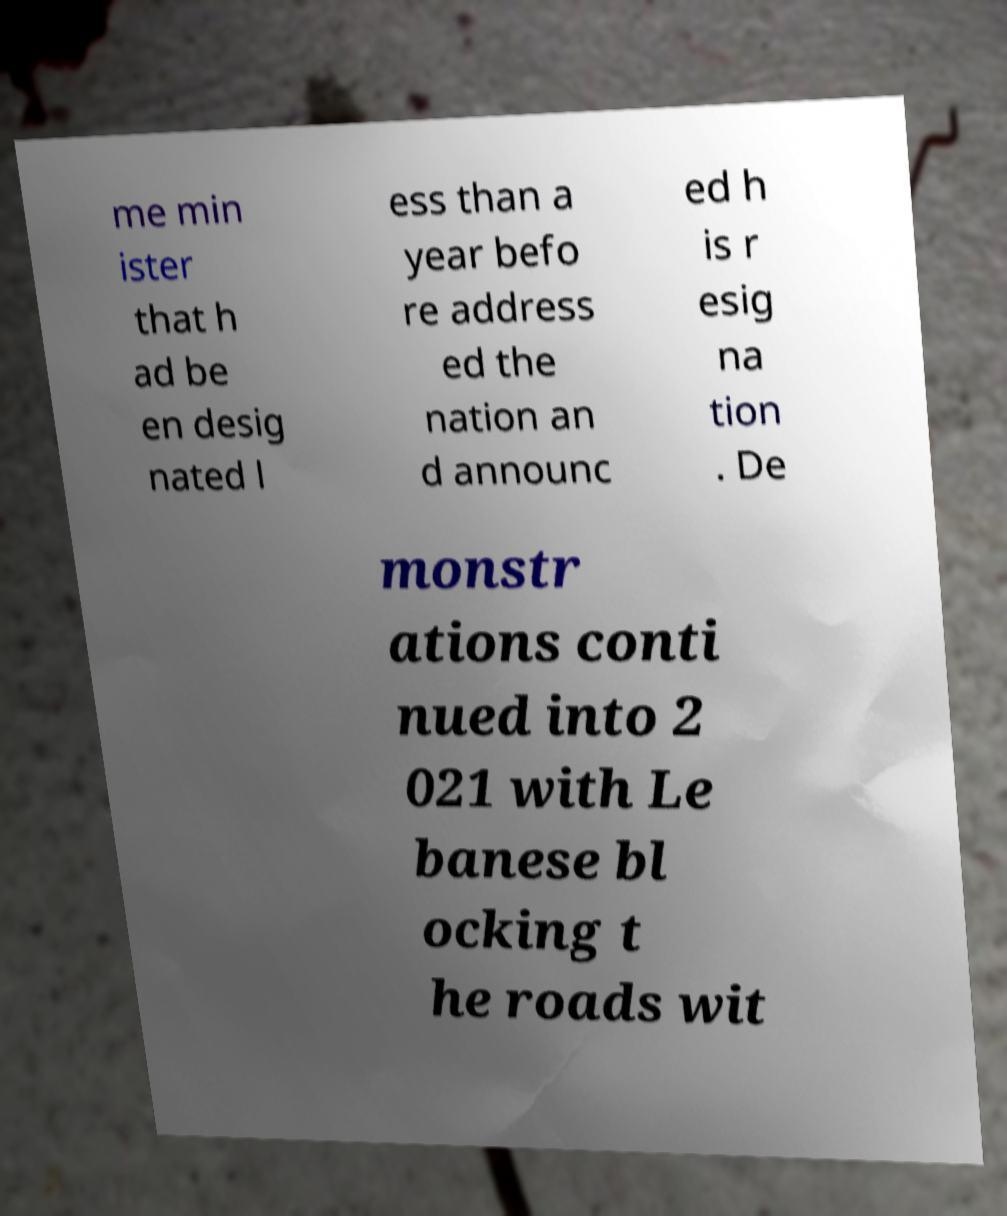Could you extract and type out the text from this image? me min ister that h ad be en desig nated l ess than a year befo re address ed the nation an d announc ed h is r esig na tion . De monstr ations conti nued into 2 021 with Le banese bl ocking t he roads wit 